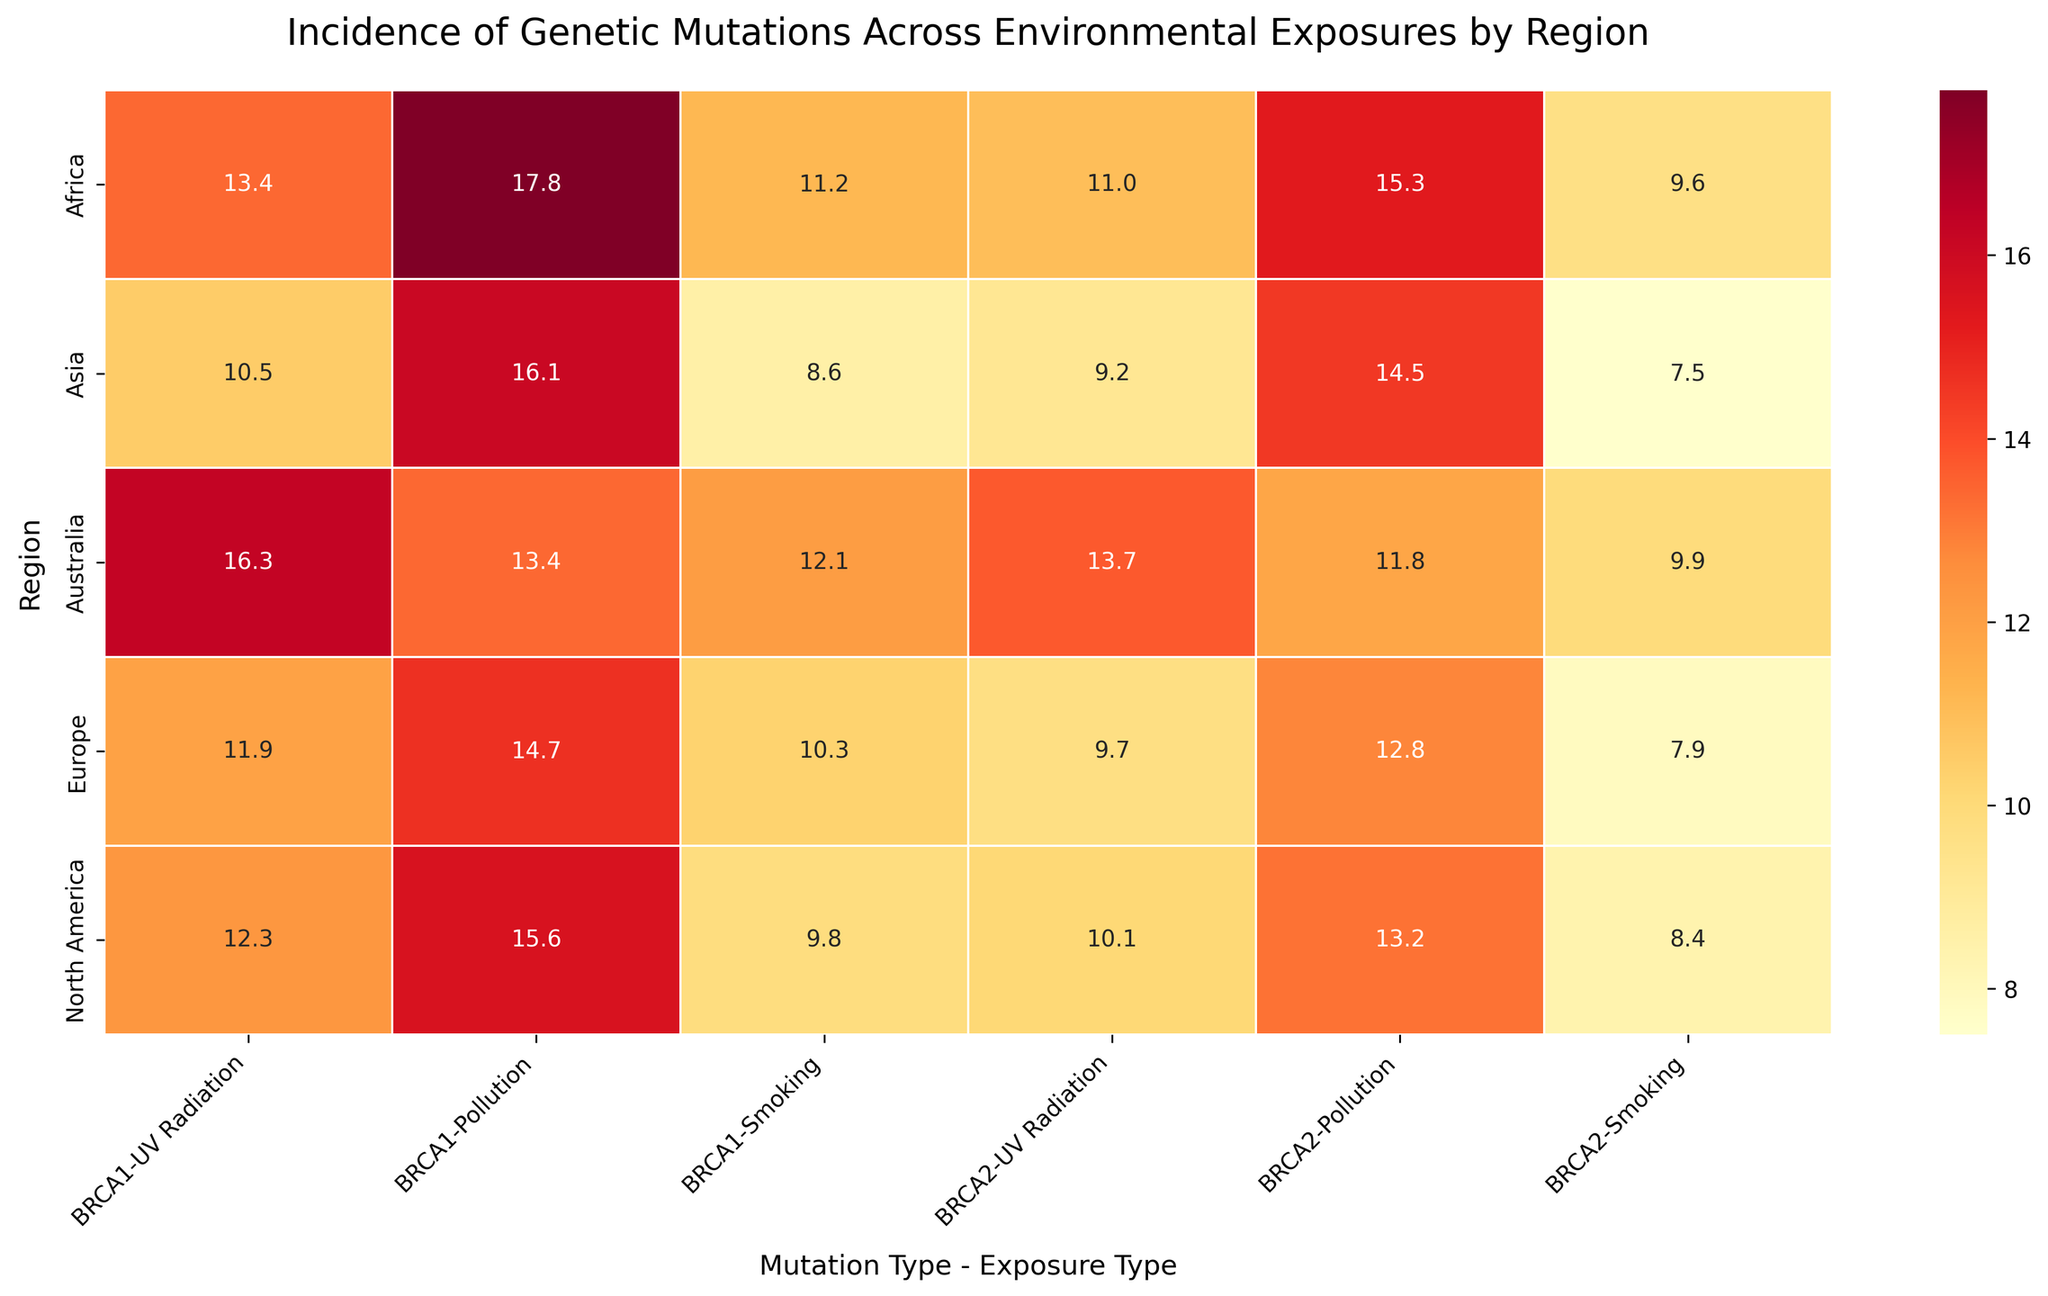What is the highest incidence rate for BRCA1 mutations in North America? To find the highest incidence rate for BRCA1 mutations in North America, locate the row for "North America" and find the highest value in the column group for BRCA1. The values are 12.3, 15.6, and 9.8. The highest value is 15.6.
Answer: 15.6 Which region has the lowest incidence rate for BRCA2 mutations due to smoking? To determine the lowest incidence rate for BRCA2 mutations due to smoking, locate the "Smoking" column under the BRCA2 mutation type for each region. The values are 8.4 (North America), 7.9 (Europe), 7.5 (Asia), 9.6 (Africa), and 9.9 (Australia). The lowest value is 7.5 in Asia.
Answer: Asia What is the average incidence rate of BRCA1 mutations due to pollution across all regions? To calculate the average, sum the incidence rates for BRCA1 mutations due to pollution in all regions: 15.6 (North America), 14.7 (Europe), 16.1 (Asia), 17.8 (Africa), and 13.4 (Australia). The total is 15.6 + 14.7 + 16.1 + 17.8 + 13.4 = 77.6. There are 5 regions, so the average is 77.6 / 5 = 15.52.
Answer: 15.52 Which exposure type leads to the highest incidence rate of BRCA1 mutations in Australia? To find out which exposure type leads to the highest incidence rate of BRCA1 mutations in Australia, locate the row for "Australia" and look at the values for BRCA1 under each exposure type. The values are 16.3 (UV Radiation), 13.4 (Pollution), and 12.1 (Smoking). The highest value is 16.3 for UV Radiation.
Answer: UV Radiation Is the incidence rate for BRCA2 mutations due to UV radiation higher in Africa or Australia? Compare the incidence rates for BRCA2 mutations due to UV radiation in Africa and Australia by locating the respective values in their rows. The values are 11.0 (Africa) and 13.7 (Australia). Since 13.7 is greater than 11.0, the incidence rate is higher in Australia.
Answer: Australia Which region shows the greatest variation in incidence rates for BRCA1 mutations? To find the region with the greatest variation, look at the incidence rates for BRCA1 mutations across all exposure types for each region. Calculate the range (difference between maximum and minimum values): North America (15.6 - 9.8 = 5.8), Europe (14.7 - 10.3 = 4.4), Asia (16.1 - 8.6 = 7.5), Africa (17.8 - 11.2 = 6.6), Australia (16.3 - 12.1 = 4.2). The greatest variation is in Asia (7.5).
Answer: Asia What is the total incidence rate for BRCA2 mutations due to pollution across North America and Europe? To find the total, sum the incidence rates for BRCA2 mutations due to pollution in North America and Europe. The values are 13.2 (North America) and 12.8 (Europe). The total is 13.2 + 12.8 = 26.0.
Answer: 26.0 Among the given regions, which has the highest overall incidence rate for genetic mutations caused by smoking? To determine which region has the highest overall incidence rate for genetic mutations caused by smoking, sum the smoking-related rates for BRCA1 and BRCA2 mutations for each region and compare. North America (9.8 + 8.4 = 18.2), Europe (10.3 + 7.9 = 18.2), Asia (8.6 + 7.5 = 16.1), Africa (11.2 + 9.6 = 20.8), Australia (12.1 + 9.9 = 22.0). Australia has the highest overall rate.
Answer: Australia 